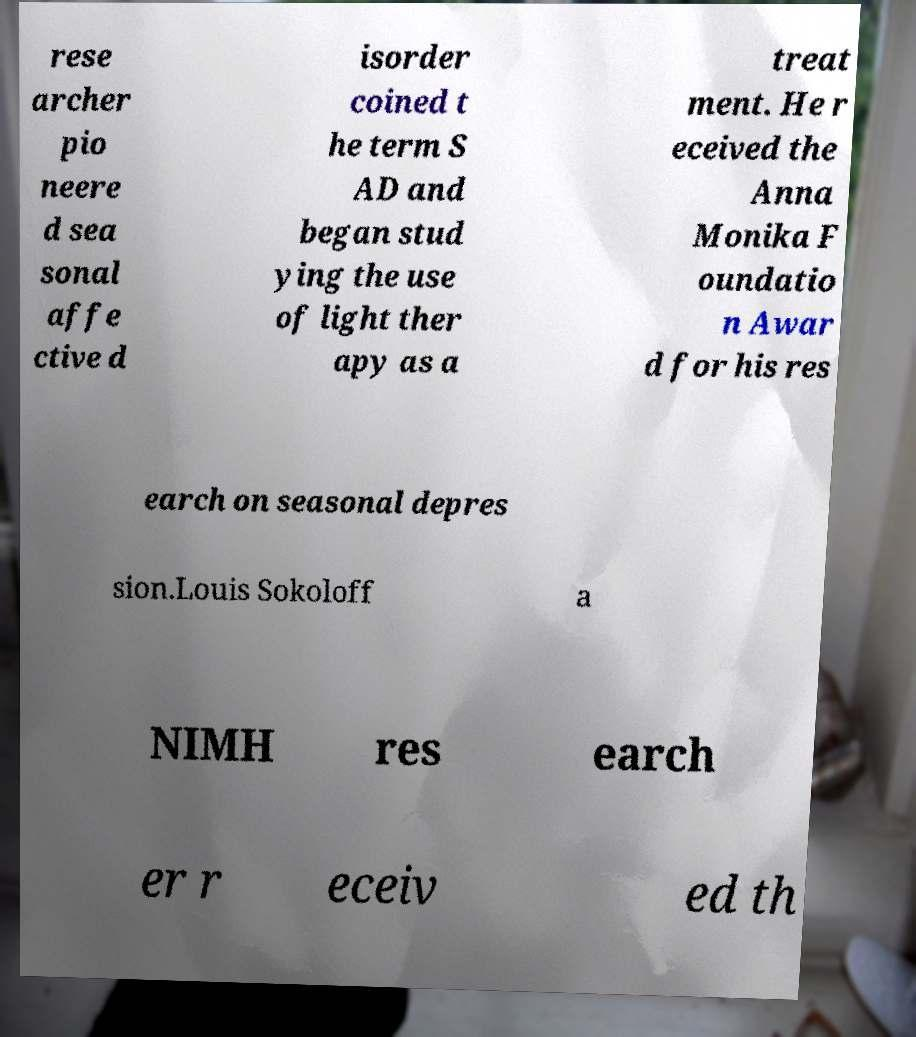Please read and relay the text visible in this image. What does it say? rese archer pio neere d sea sonal affe ctive d isorder coined t he term S AD and began stud ying the use of light ther apy as a treat ment. He r eceived the Anna Monika F oundatio n Awar d for his res earch on seasonal depres sion.Louis Sokoloff a NIMH res earch er r eceiv ed th 